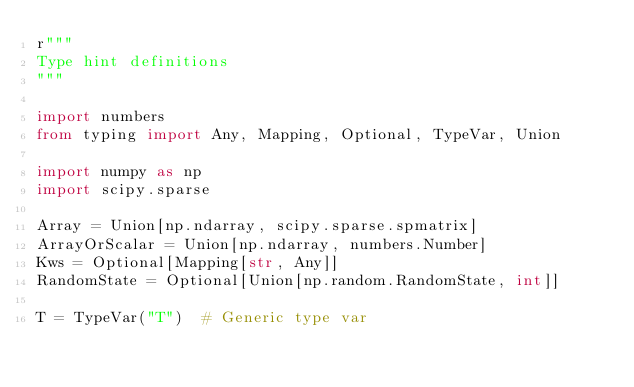Convert code to text. <code><loc_0><loc_0><loc_500><loc_500><_Python_>r"""
Type hint definitions
"""

import numbers
from typing import Any, Mapping, Optional, TypeVar, Union

import numpy as np
import scipy.sparse

Array = Union[np.ndarray, scipy.sparse.spmatrix]
ArrayOrScalar = Union[np.ndarray, numbers.Number]
Kws = Optional[Mapping[str, Any]]
RandomState = Optional[Union[np.random.RandomState, int]]

T = TypeVar("T")  # Generic type var
</code> 